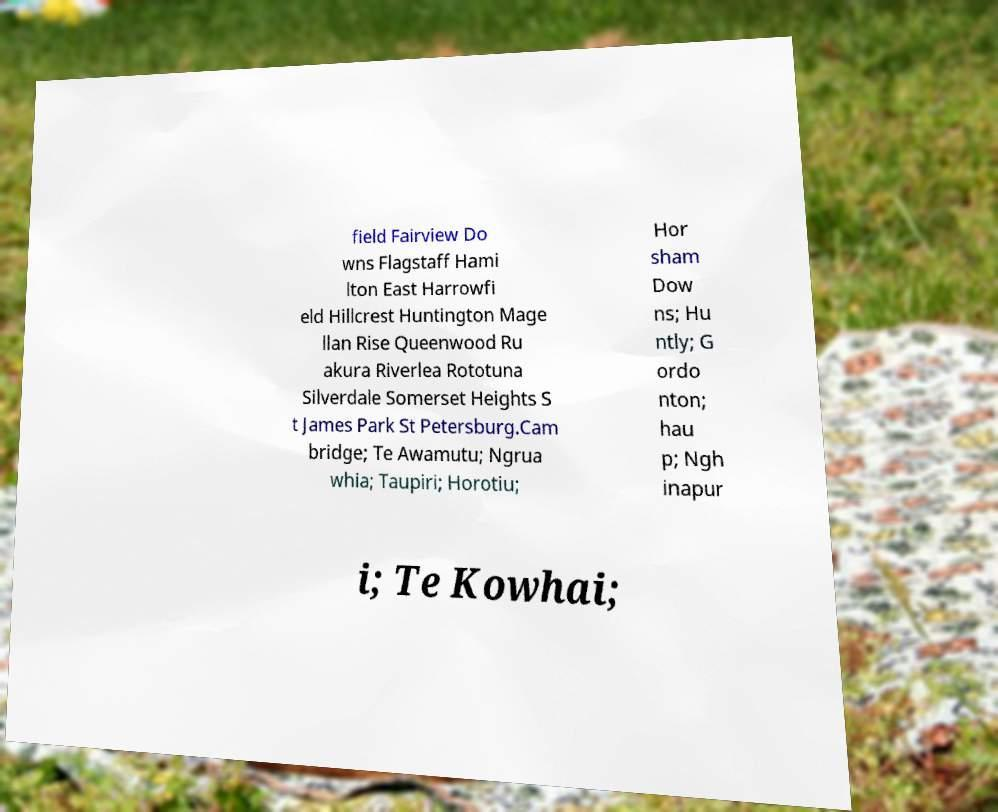Could you assist in decoding the text presented in this image and type it out clearly? field Fairview Do wns Flagstaff Hami lton East Harrowfi eld Hillcrest Huntington Mage llan Rise Queenwood Ru akura Riverlea Rototuna Silverdale Somerset Heights S t James Park St Petersburg.Cam bridge; Te Awamutu; Ngrua whia; Taupiri; Horotiu; Hor sham Dow ns; Hu ntly; G ordo nton; hau p; Ngh inapur i; Te Kowhai; 